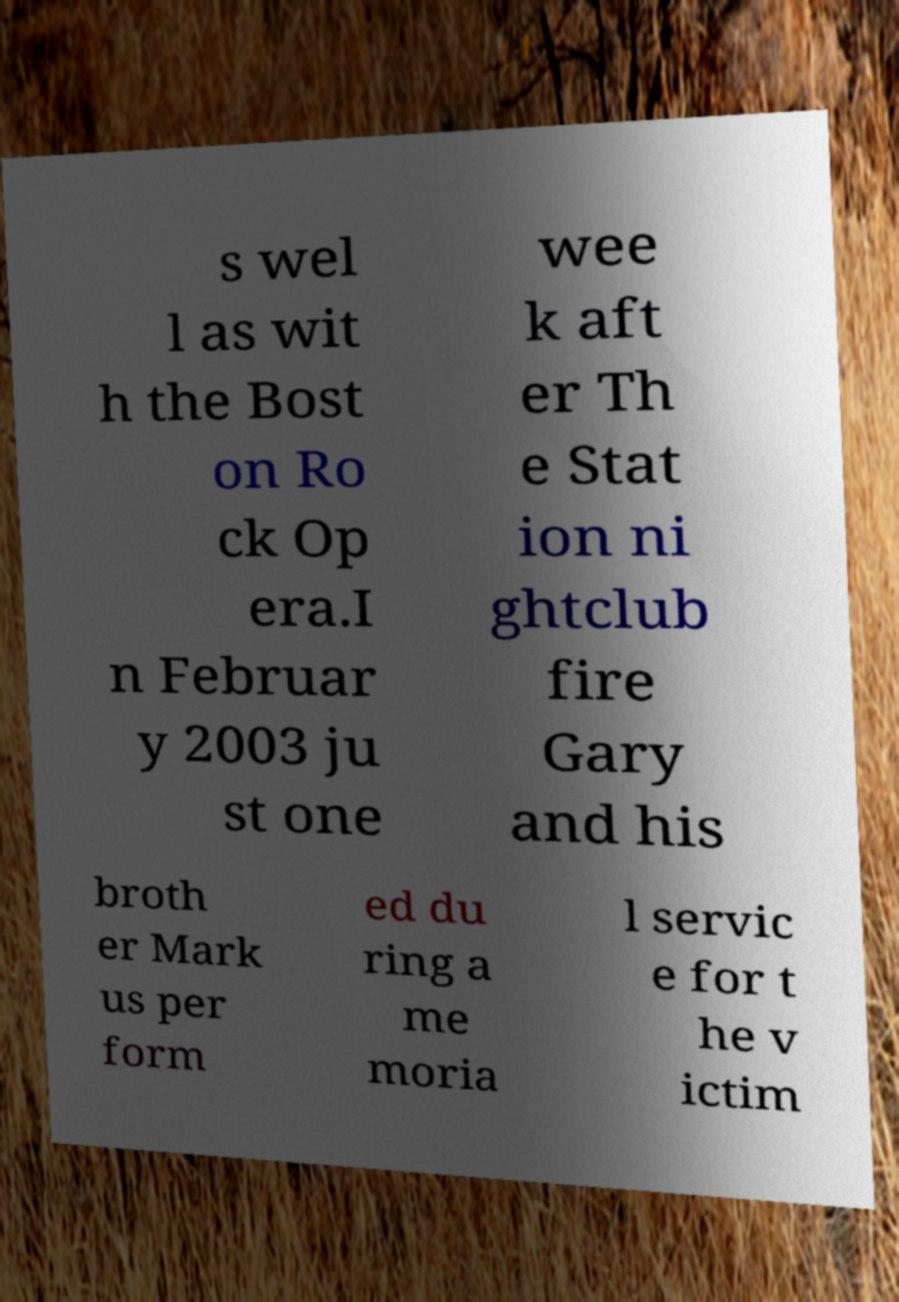Can you accurately transcribe the text from the provided image for me? s wel l as wit h the Bost on Ro ck Op era.I n Februar y 2003 ju st one wee k aft er Th e Stat ion ni ghtclub fire Gary and his broth er Mark us per form ed du ring a me moria l servic e for t he v ictim 